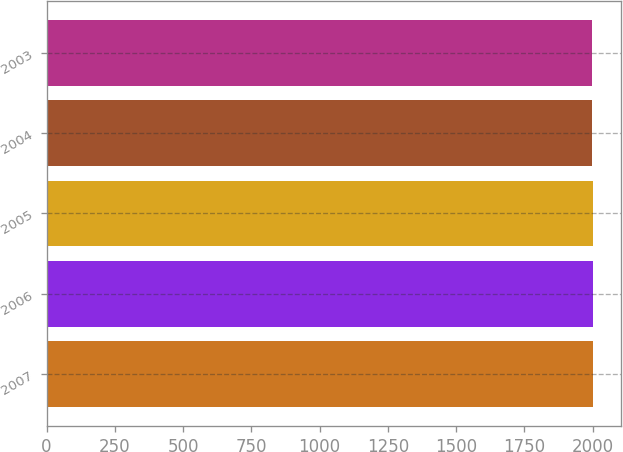Convert chart. <chart><loc_0><loc_0><loc_500><loc_500><bar_chart><fcel>2007<fcel>2006<fcel>2005<fcel>2004<fcel>2003<nl><fcel>2002<fcel>2001<fcel>2000<fcel>1999<fcel>1998<nl></chart> 